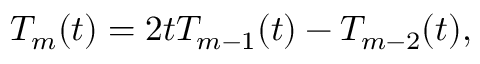<formula> <loc_0><loc_0><loc_500><loc_500>T _ { m } ( t ) = 2 t T _ { m - 1 } ( t ) - T _ { m - 2 } ( t ) ,</formula> 